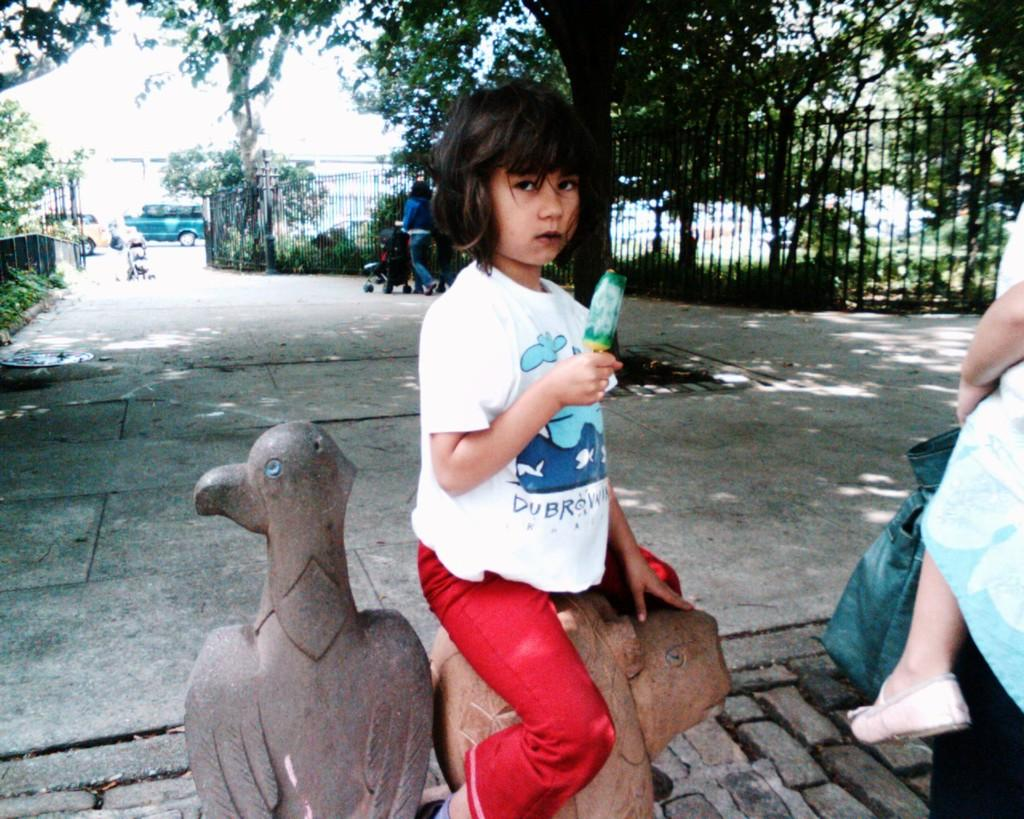What are the persons in the image doing? The persons in the image are walking on the road, and they are holding baby prams. What are the children doing in the image? The children are sitting on statues. What type of objects can be seen in the image related to cooking or food preparation? There are grills in the image. What type of vegetation is present in the image? Trees and shrubs are visible in the image. What type of transportation is present in the image? Motor vehicles are in the image. What part of the natural environment is visible in the image? The sky is visible in the image. Can you tell me how many elbows are visible in the image? There is no mention of elbows in the provided facts, so it is impossible to determine how many elbows are visible in the image. What type of shade is provided by the trees in the image? The provided facts do not mention any shade provided by the trees; they only mention the presence of trees in the image. 